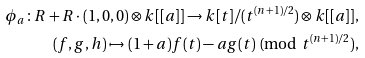Convert formula to latex. <formula><loc_0><loc_0><loc_500><loc_500>\phi _ { a } \colon R + R \cdot ( 1 , 0 , 0 ) \otimes k [ [ a ] ] \to k [ t ] / ( t ^ { ( n + 1 ) / 2 } ) \otimes k [ [ a ] ] , \\ ( f , g , h ) \mapsto ( 1 + a ) f ( t ) - a g ( t ) \text { (mod $t^{(n+1)/2})$,}</formula> 